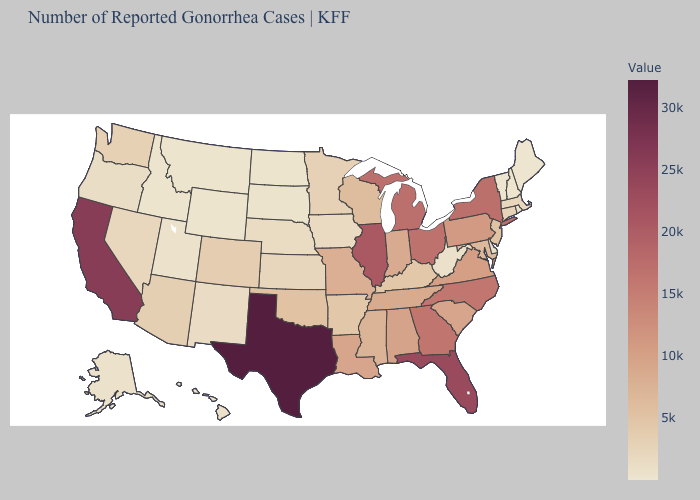Does Montana have the lowest value in the West?
Keep it brief. Yes. Which states have the lowest value in the USA?
Write a very short answer. Vermont. Which states have the highest value in the USA?
Write a very short answer. Texas. 